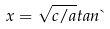Convert formula to latex. <formula><loc_0><loc_0><loc_500><loc_500>x = \sqrt { c / a } t a n \theta</formula> 